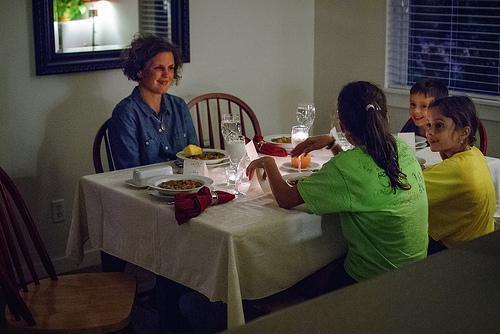How many people are at the table?
Give a very brief answer. 4. 